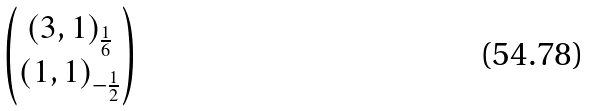Convert formula to latex. <formula><loc_0><loc_0><loc_500><loc_500>\begin{pmatrix} ( 3 , 1 ) _ { \frac { 1 } { 6 } } \\ ( 1 , 1 ) _ { - \frac { 1 } { 2 } } \end{pmatrix}</formula> 